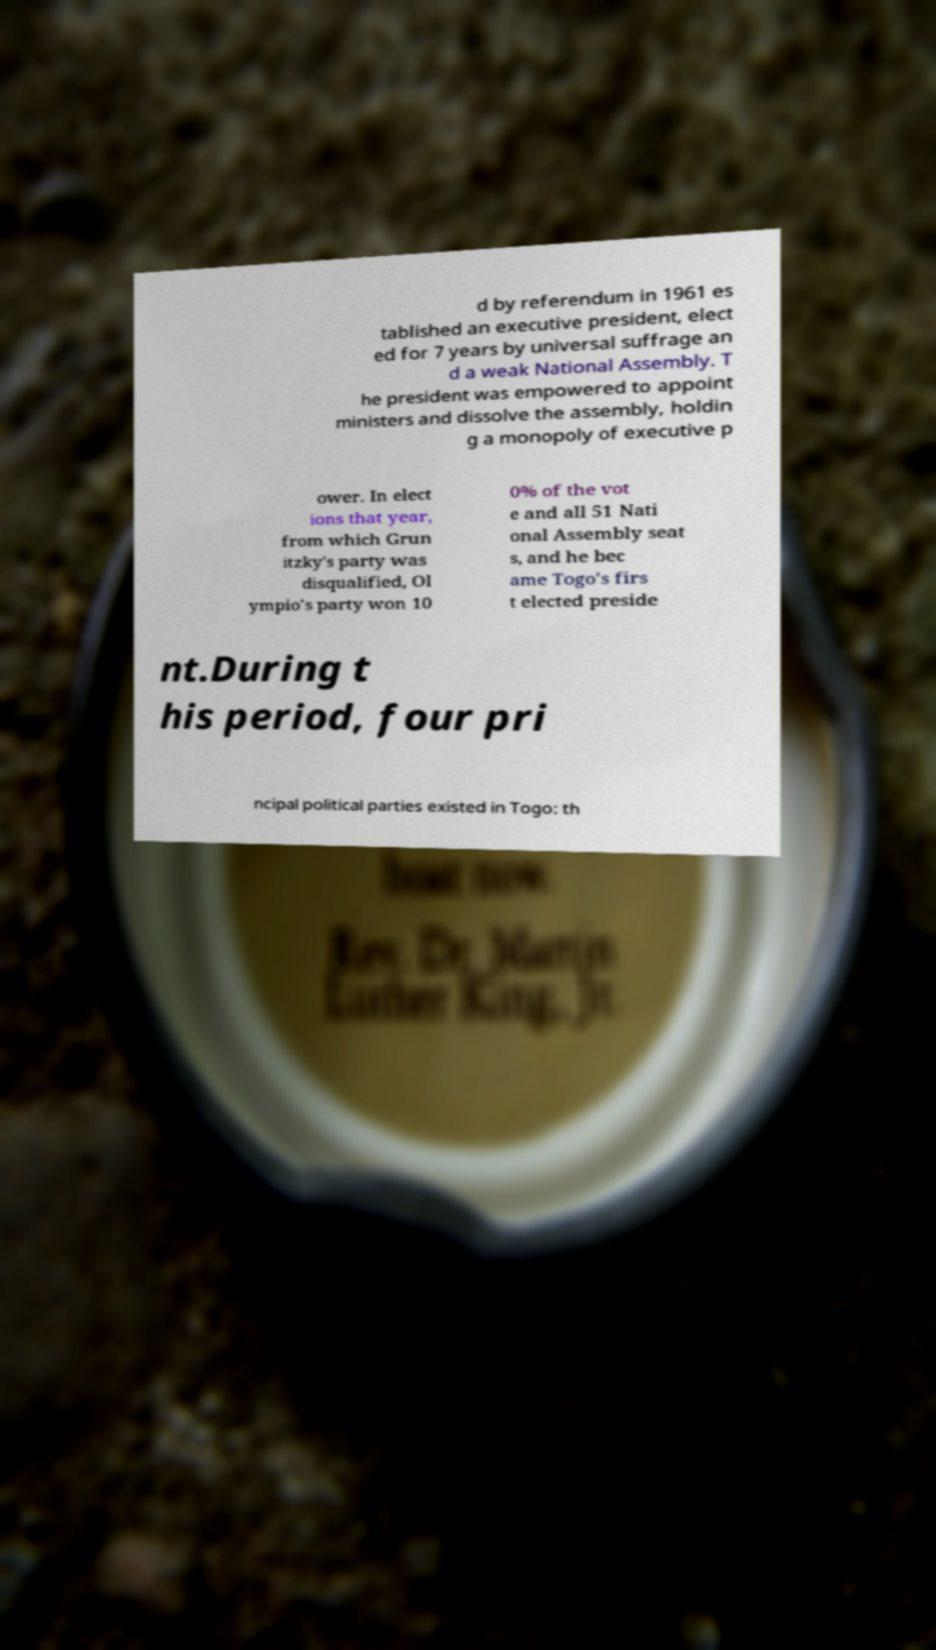Could you extract and type out the text from this image? d by referendum in 1961 es tablished an executive president, elect ed for 7 years by universal suffrage an d a weak National Assembly. T he president was empowered to appoint ministers and dissolve the assembly, holdin g a monopoly of executive p ower. In elect ions that year, from which Grun itzky's party was disqualified, Ol ympio's party won 10 0% of the vot e and all 51 Nati onal Assembly seat s, and he bec ame Togo's firs t elected preside nt.During t his period, four pri ncipal political parties existed in Togo: th 